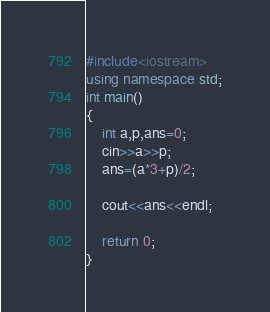<code> <loc_0><loc_0><loc_500><loc_500><_C++_>#include<iostream>
using namespace std;
int main()
{
    int a,p,ans=0;
    cin>>a>>p;
    ans=(a*3+p)/2;

    cout<<ans<<endl;

    return 0;
}
</code> 